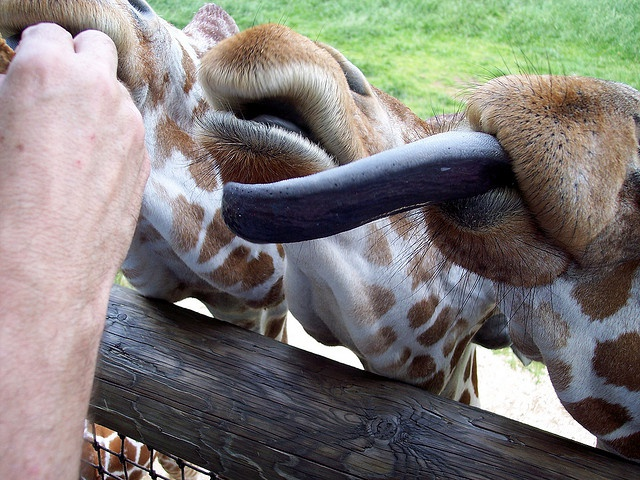Describe the objects in this image and their specific colors. I can see giraffe in gray, black, and darkgray tones, giraffe in gray, darkgray, black, and lightgray tones, people in gray, lightgray, darkgray, and pink tones, and giraffe in turquoise, gray, lightgray, darkgray, and black tones in this image. 